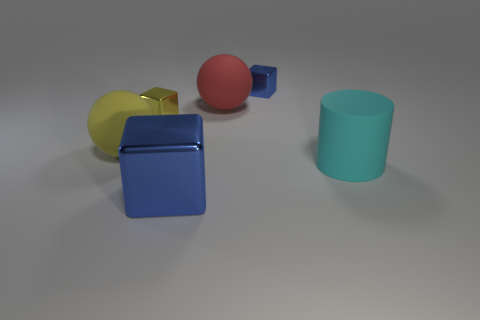What number of balls have the same size as the yellow cube? Upon examining the image, it appears that there are no balls which share the same size as the yellow cube. 